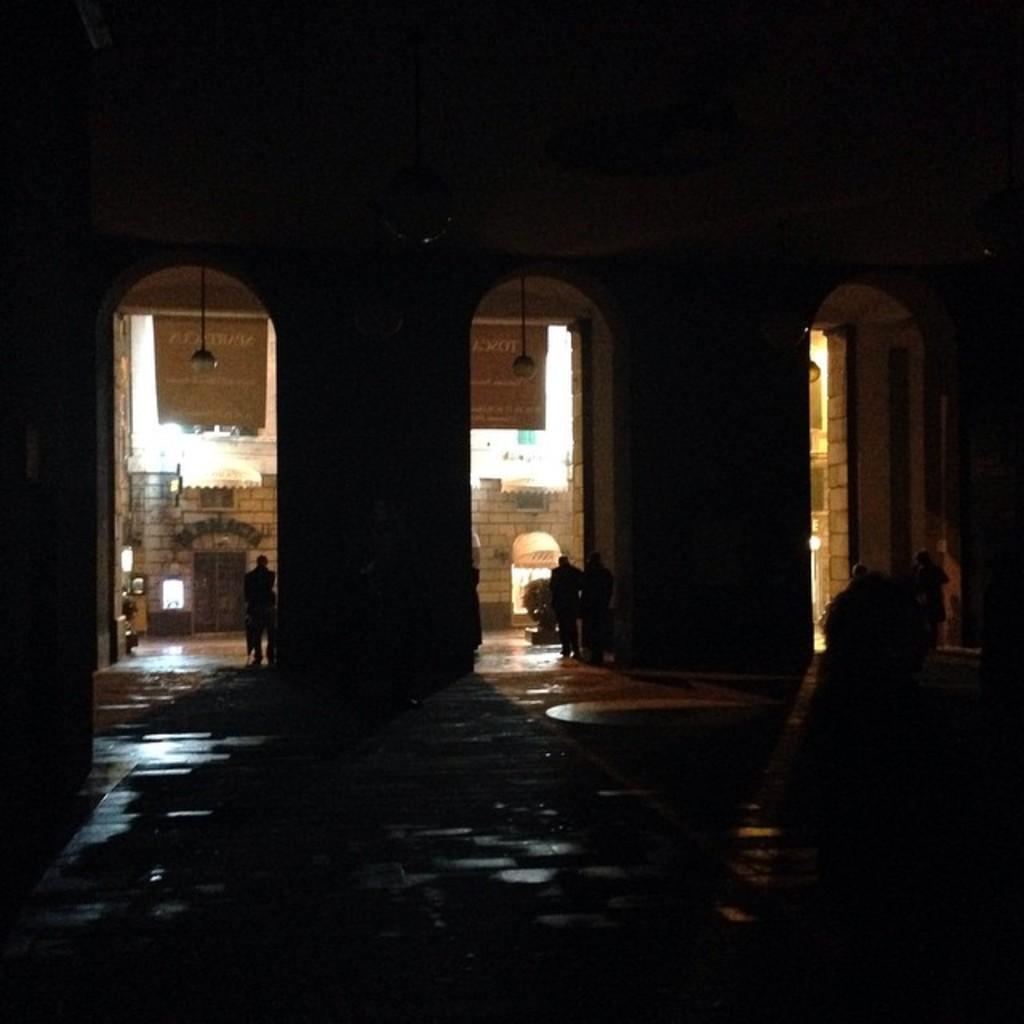In one or two sentences, can you explain what this image depicts? In the image we can see a building, in the building we can see some persons. 